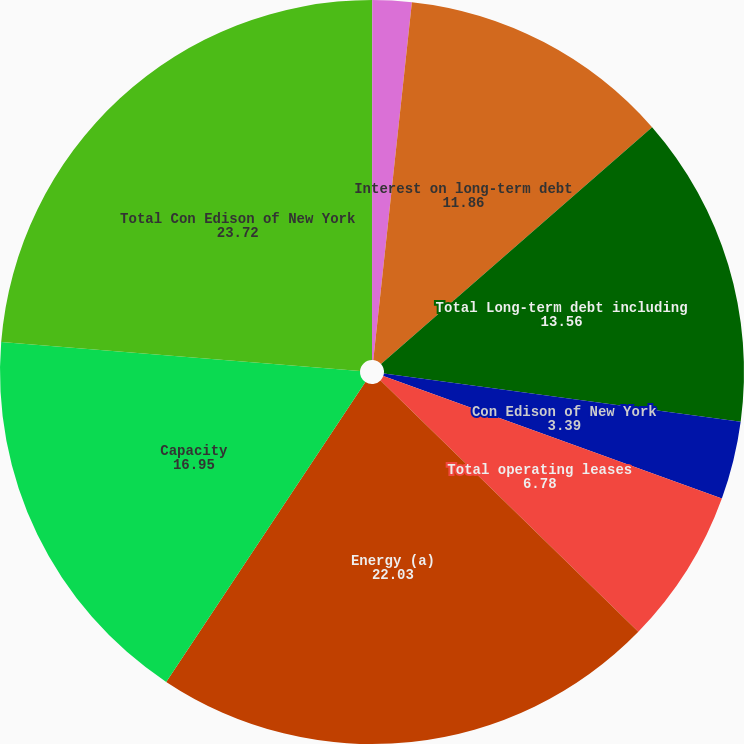Convert chart to OTSL. <chart><loc_0><loc_0><loc_500><loc_500><pie_chart><fcel>O&R<fcel>Competitive energy businesses<fcel>Interest on long-term debt<fcel>Total Long-term debt including<fcel>Con Edison of New York<fcel>Total operating leases<fcel>Energy (a)<fcel>Capacity<fcel>Total Con Edison of New York<nl><fcel>0.01%<fcel>1.7%<fcel>11.86%<fcel>13.56%<fcel>3.39%<fcel>6.78%<fcel>22.03%<fcel>16.95%<fcel>23.72%<nl></chart> 